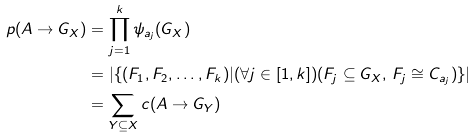Convert formula to latex. <formula><loc_0><loc_0><loc_500><loc_500>p ( A \rightarrow G _ { X } ) & = \prod _ { j = 1 } ^ { k } \psi _ { a _ { j } } ( G _ { X } ) \\ & = | \{ ( F _ { 1 } , F _ { 2 } , \dots , F _ { k } ) | ( \forall j \in [ 1 , k ] ) ( F _ { j } \subseteq G _ { X } , \, F _ { j } \cong C _ { a _ { j } } ) \} | \\ & = \sum _ { Y \subseteq X } c ( A \rightarrow G _ { Y } )</formula> 